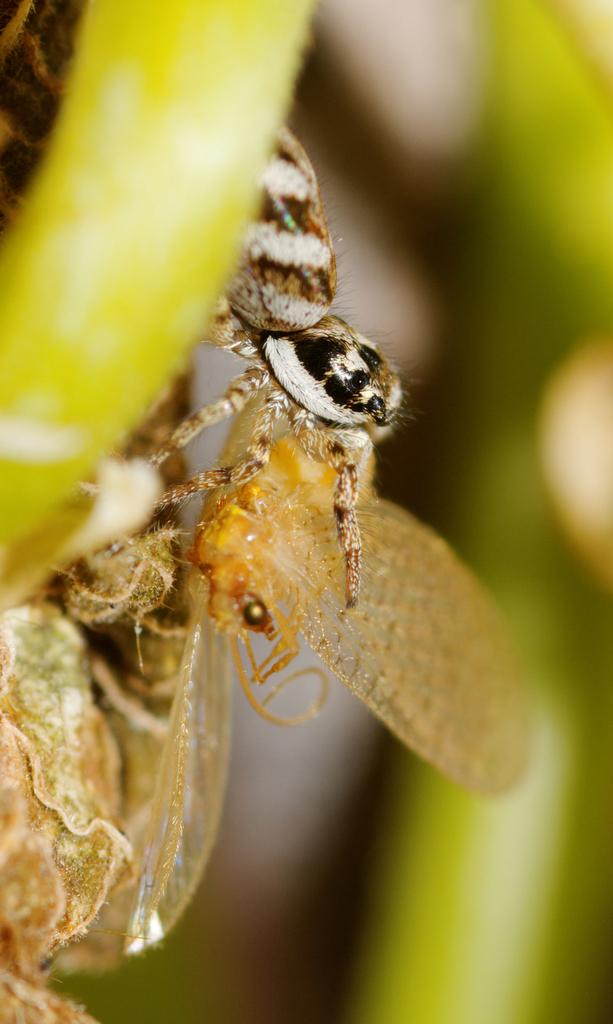What type of animal can be seen in the image? There is an insect and a butterfly in the image. Can you describe the insect and the butterfly? The insect and the butterfly are both small, winged creatures. What is the object they are on in the image? The object they are on is unclear from the provided facts. What shape is the sister's dress in the image? There is no mention of a sister or a dress in the image, so we cannot answer this question. 